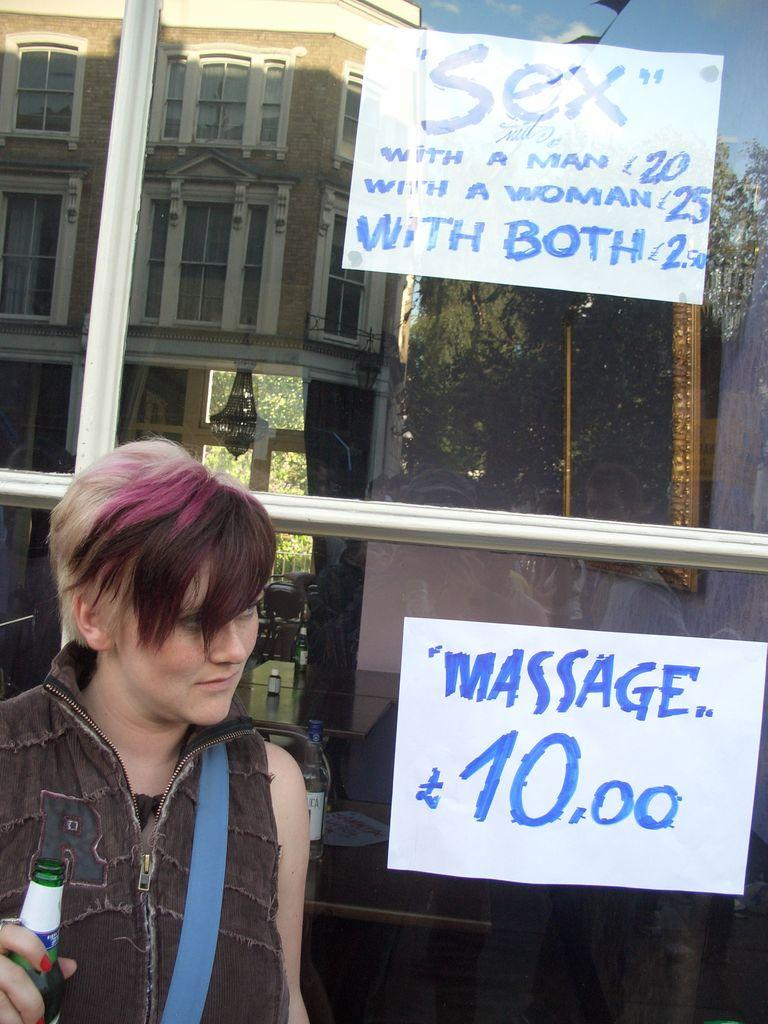Who is present in the image? There is a woman in the image. What is the woman wearing? The woman is wearing a jacket. What is the woman carrying? The woman is carrying a backpack. What is the woman holding in her hand? The woman is holding a bottle in her hand. What type of door is visible in the image? There is a glass door visible in the image. What can be seen on the walls in the image? There are name boards in the image. What type of coach is visible in the image? There is no coach present in the image. 